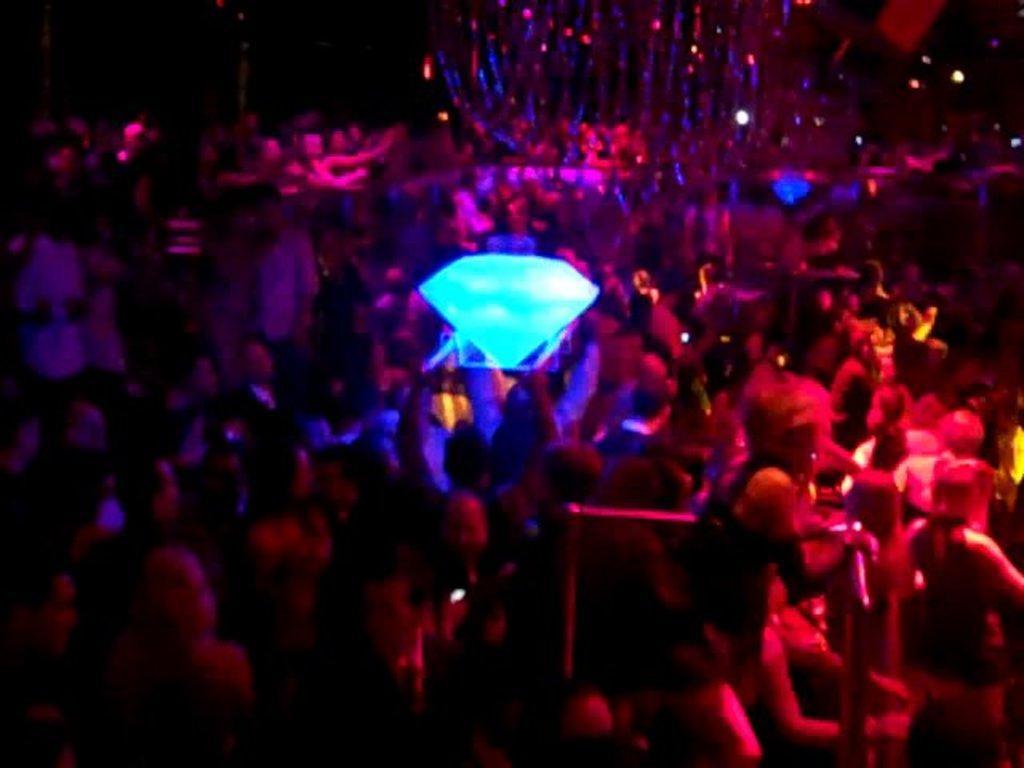How would you summarize this image in a sentence or two? In this image I can see the group of people. In-between these people I can see the blue color object which is in diamond shape. 